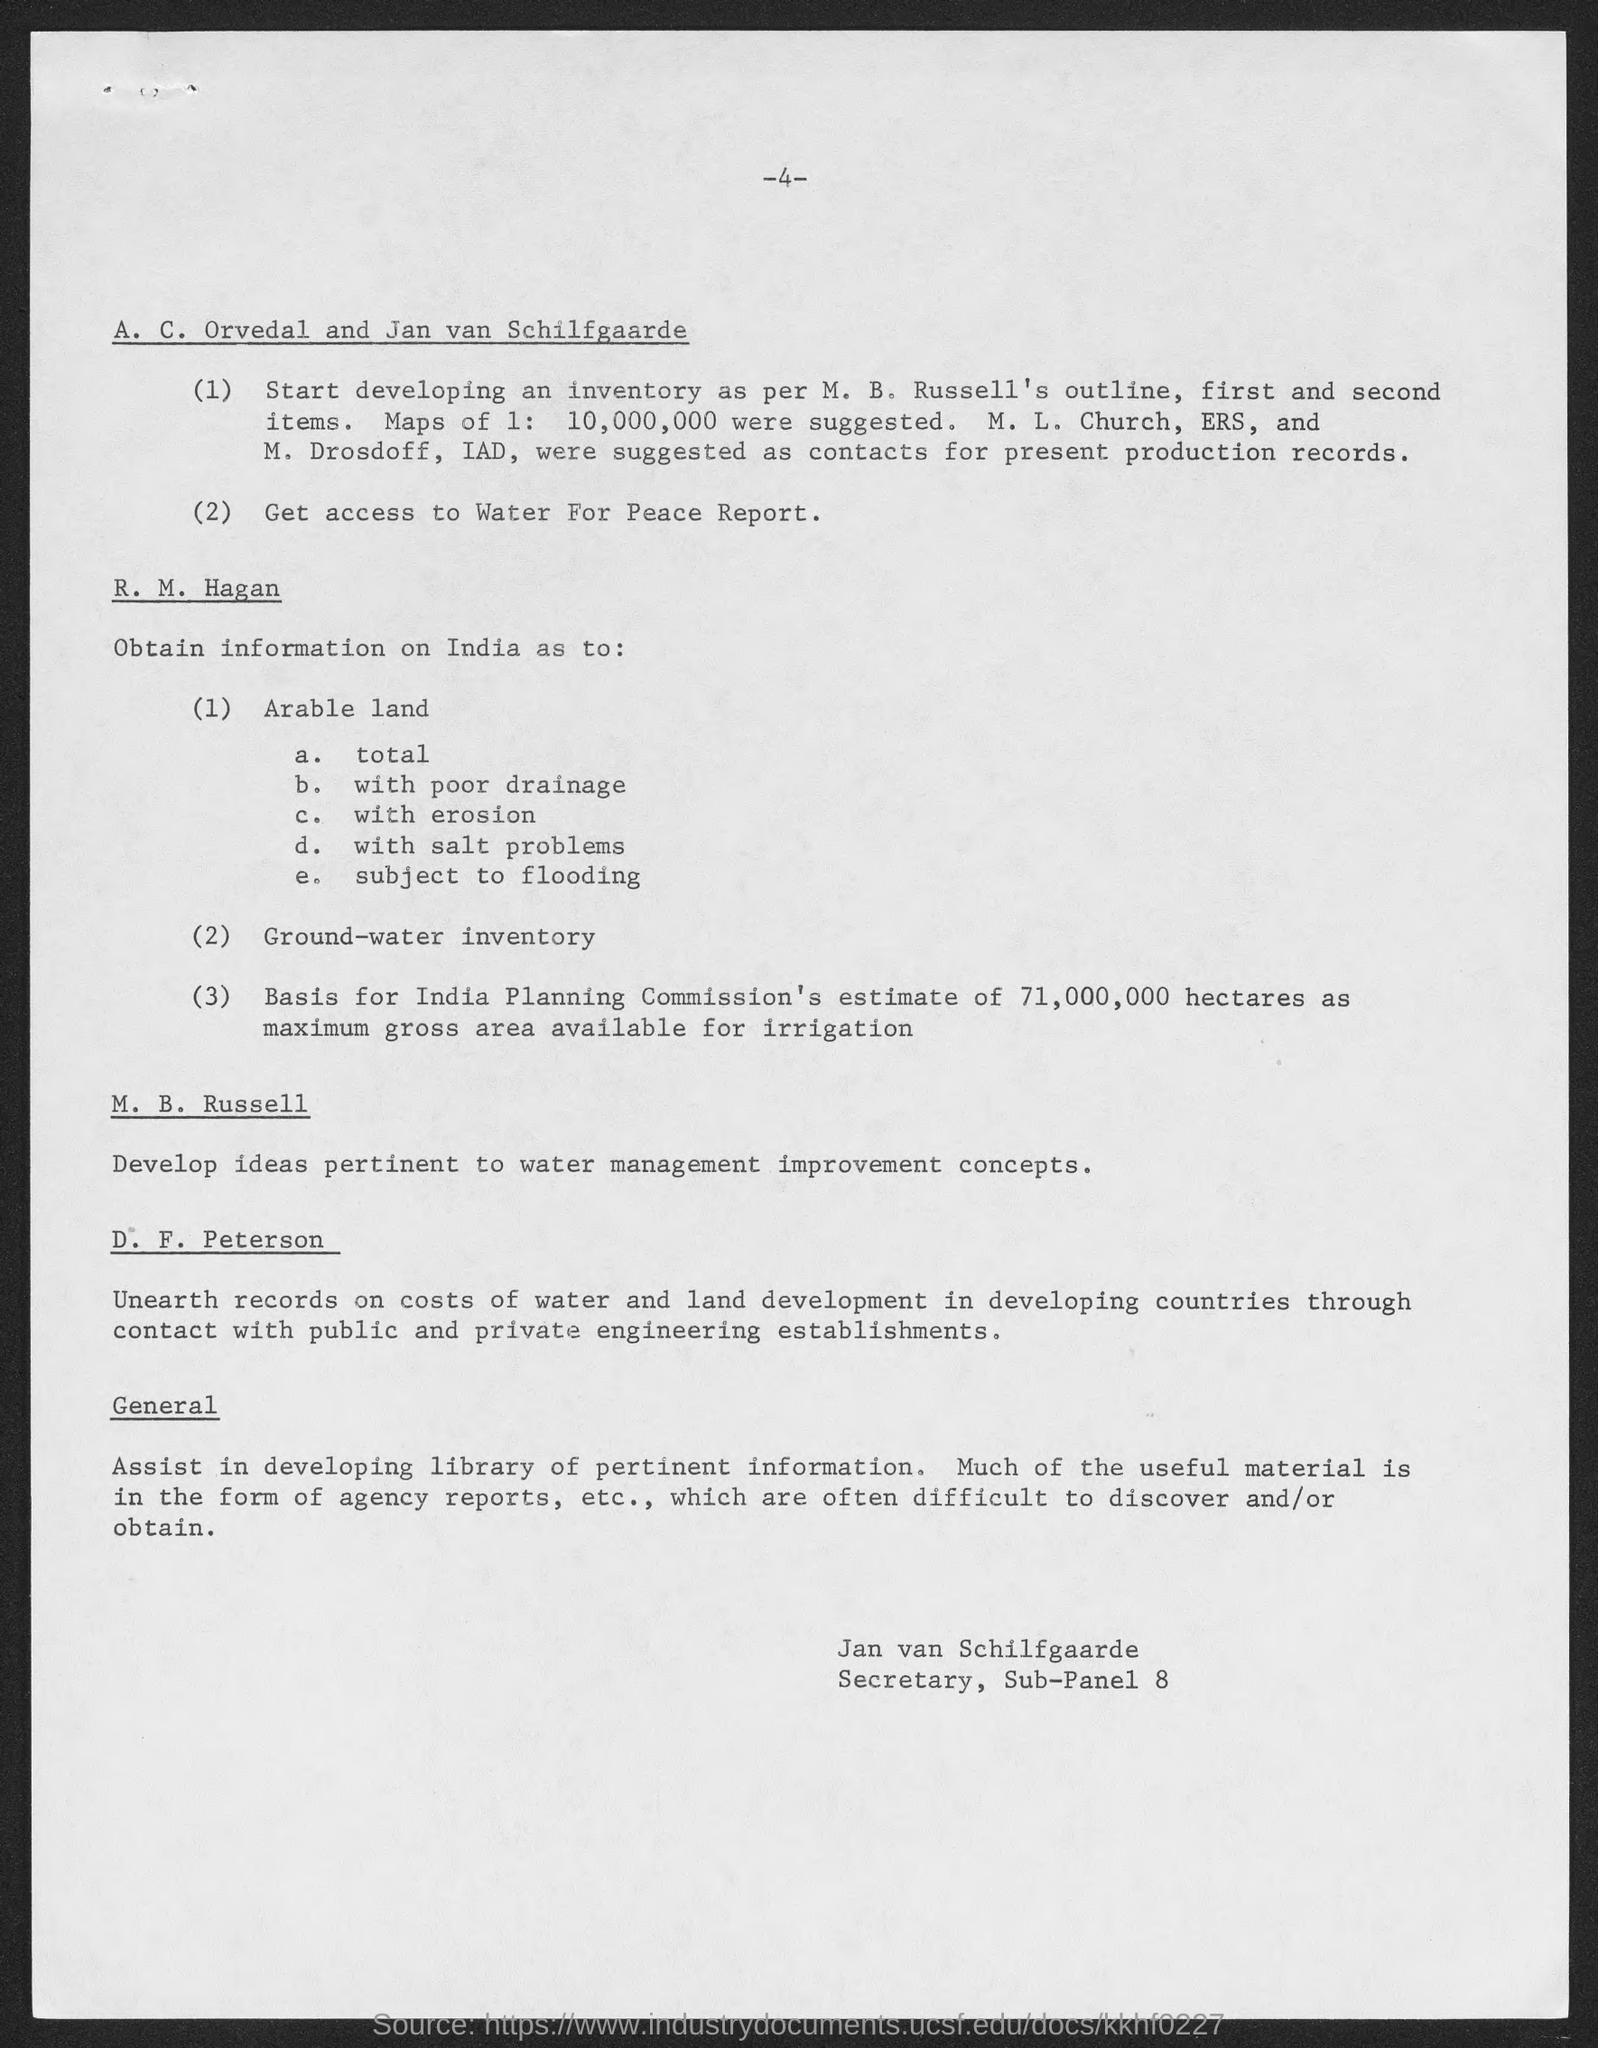Who is the secretary of Sub-panel 8?
Make the answer very short. Jan van Schilfgaarde. What is the maximum gross area available for irrigation on basis of India Planning Commission?
Offer a terse response. 71,000,000 hectares. Who is in charge of development of ideas pertinent to water management improvement concepts?
Keep it short and to the point. M. B. Russell. 